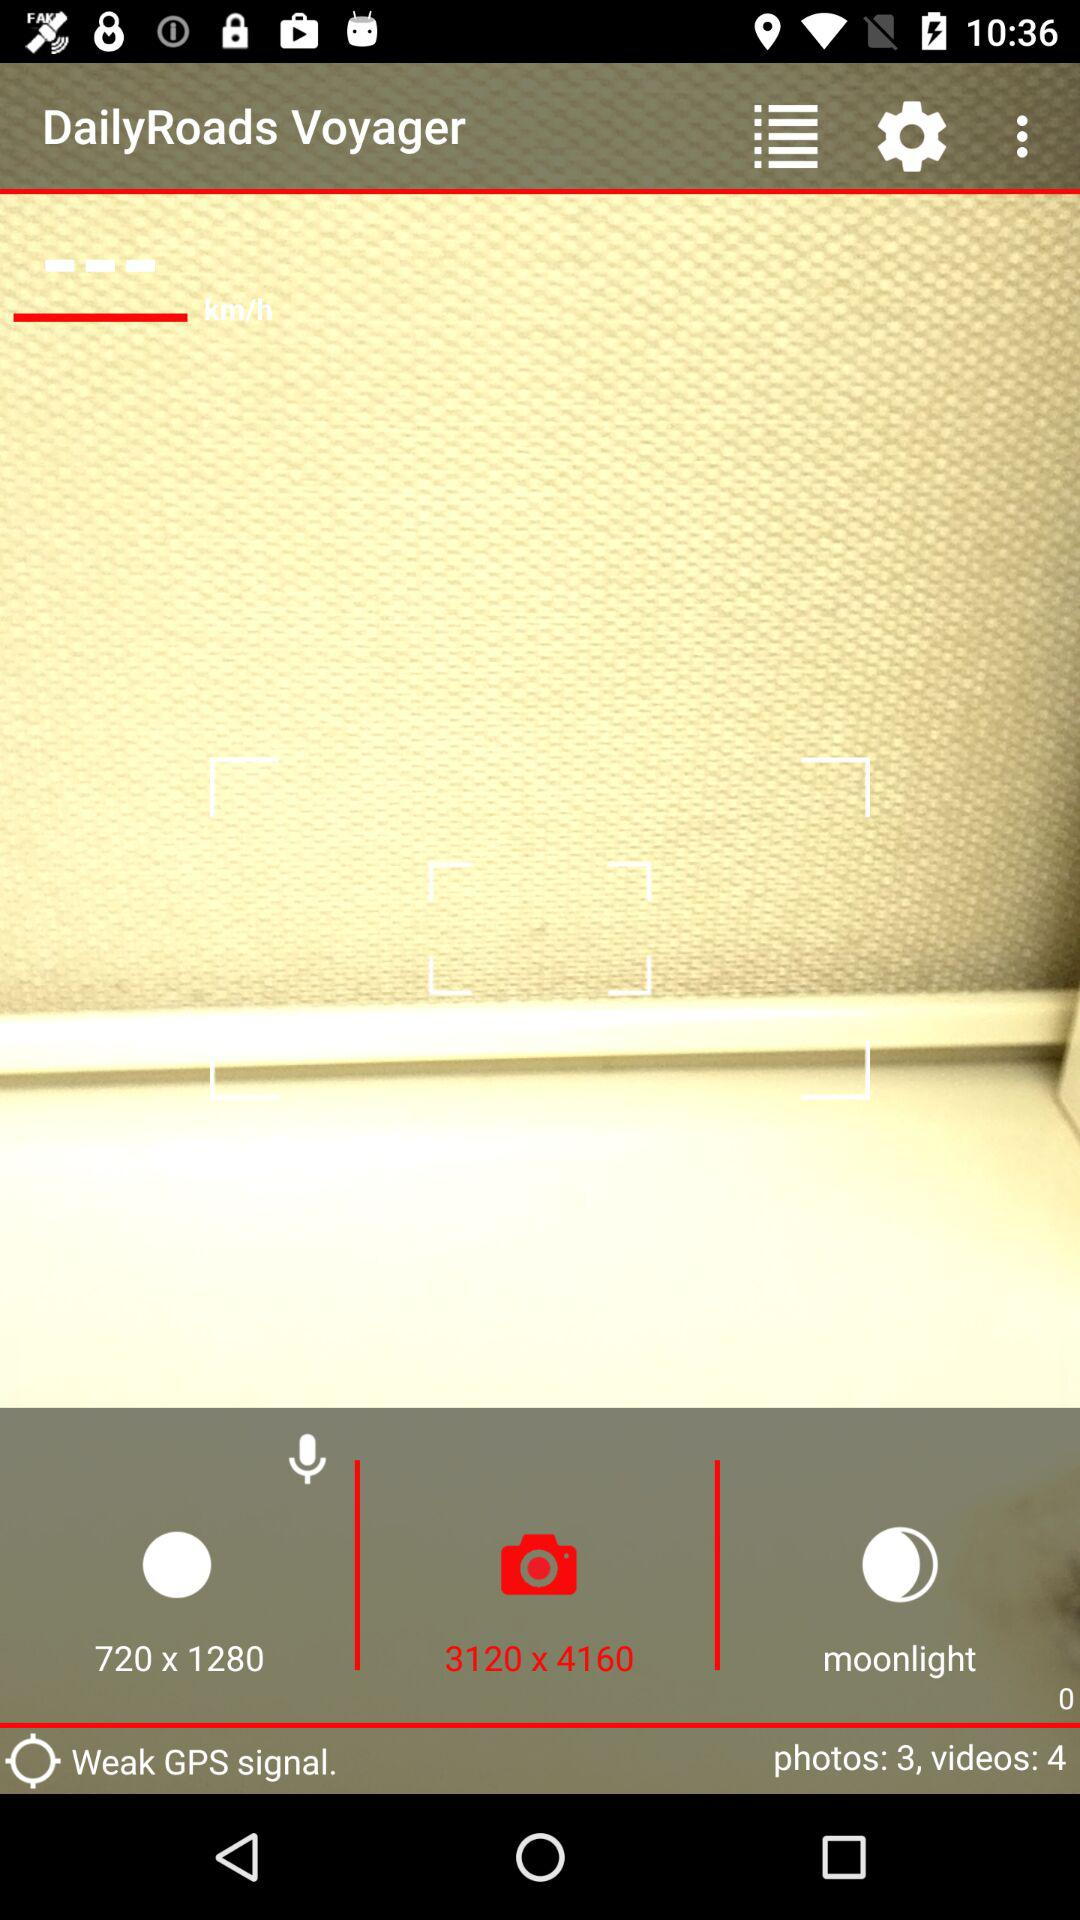In which resolution am I clicking pictures? You are clicking pictures at a resolution of 3120 x 4160. 